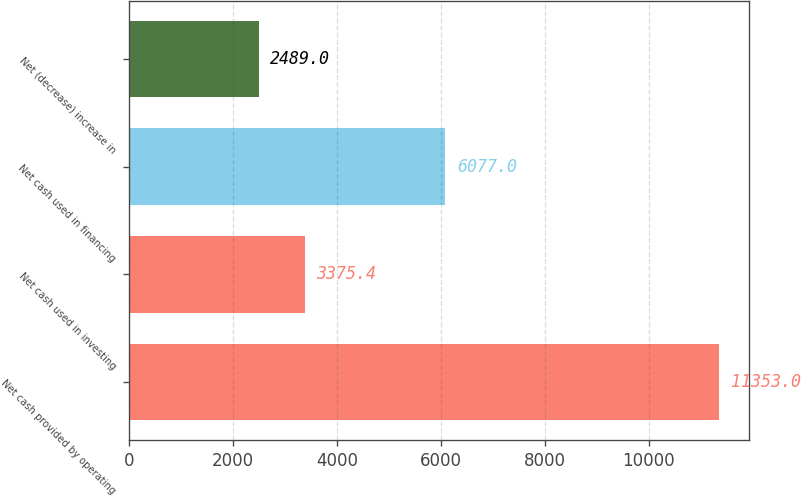Convert chart. <chart><loc_0><loc_0><loc_500><loc_500><bar_chart><fcel>Net cash provided by operating<fcel>Net cash used in investing<fcel>Net cash used in financing<fcel>Net (decrease) increase in<nl><fcel>11353<fcel>3375.4<fcel>6077<fcel>2489<nl></chart> 